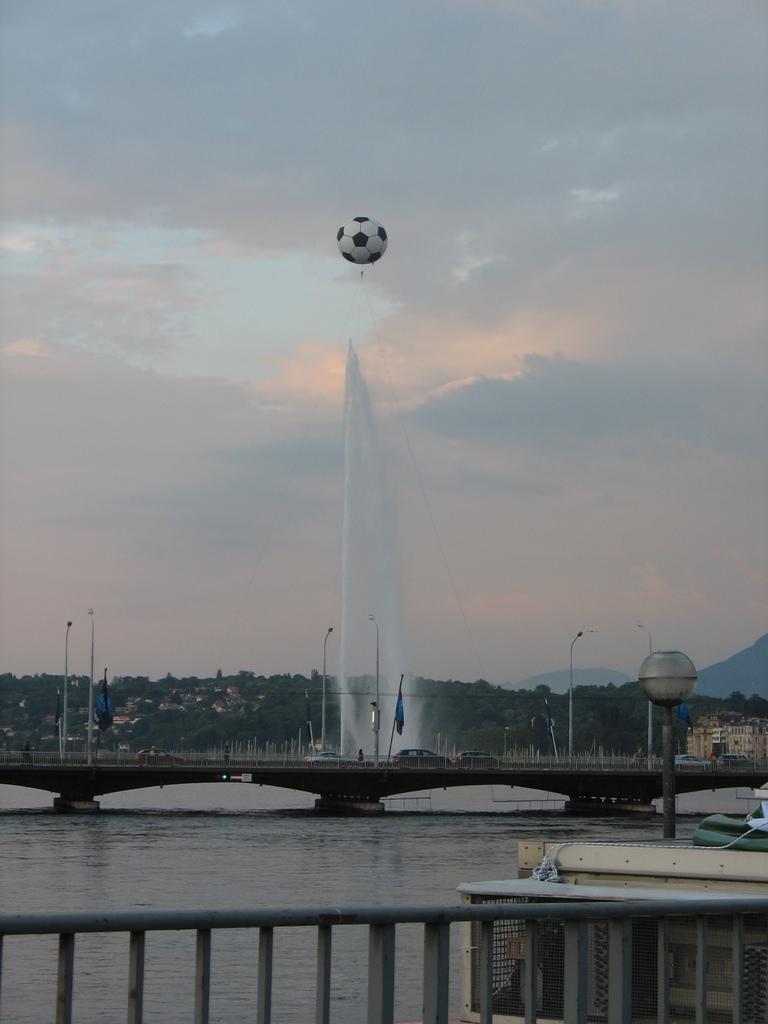Please provide a concise description of this image. In the center of the image there are cars on the bridge. There is a fountain. There are flags. There are street lights. In front of the image there is a metal fence. There are ships in the water. On top of the image there is a ball. In the background of the image there are trees, buildings and sky. 